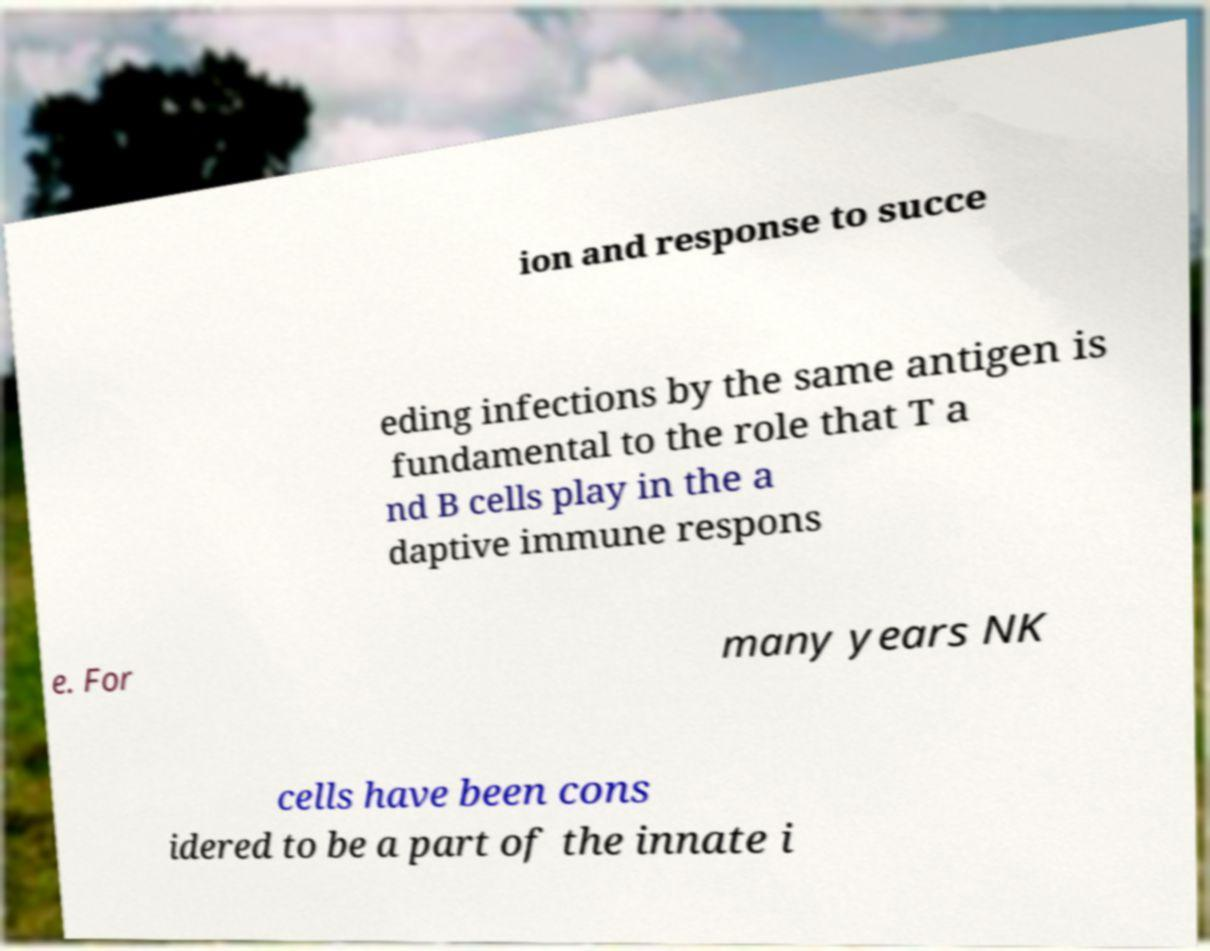Could you assist in decoding the text presented in this image and type it out clearly? ion and response to succe eding infections by the same antigen is fundamental to the role that T a nd B cells play in the a daptive immune respons e. For many years NK cells have been cons idered to be a part of the innate i 